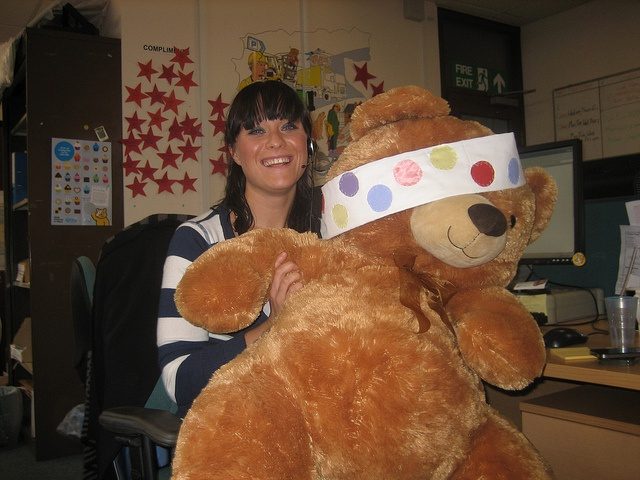Describe the objects in this image and their specific colors. I can see teddy bear in black, brown, maroon, and gray tones, people in black, brown, and darkgray tones, chair in black, purple, and gray tones, tv in black, gray, and olive tones, and cup in black and gray tones in this image. 